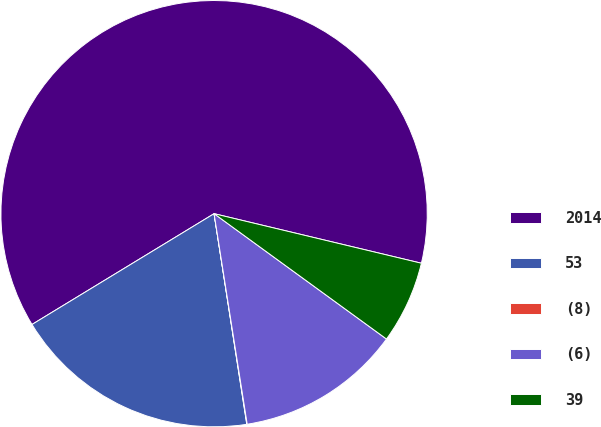Convert chart. <chart><loc_0><loc_0><loc_500><loc_500><pie_chart><fcel>2014<fcel>53<fcel>(8)<fcel>(6)<fcel>39<nl><fcel>62.43%<fcel>18.75%<fcel>0.03%<fcel>12.51%<fcel>6.27%<nl></chart> 